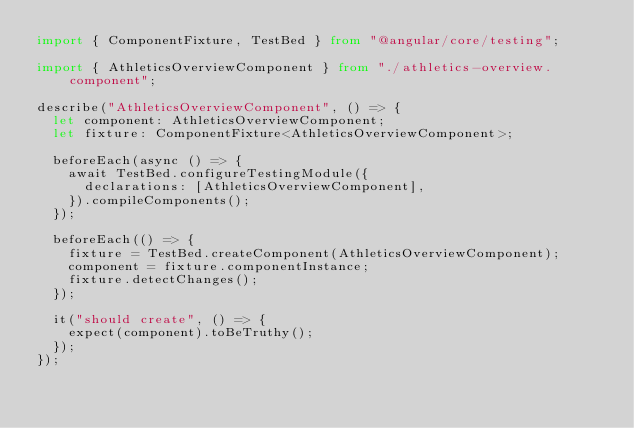<code> <loc_0><loc_0><loc_500><loc_500><_TypeScript_>import { ComponentFixture, TestBed } from "@angular/core/testing";

import { AthleticsOverviewComponent } from "./athletics-overview.component";

describe("AthleticsOverviewComponent", () => {
  let component: AthleticsOverviewComponent;
  let fixture: ComponentFixture<AthleticsOverviewComponent>;

  beforeEach(async () => {
    await TestBed.configureTestingModule({
      declarations: [AthleticsOverviewComponent],
    }).compileComponents();
  });

  beforeEach(() => {
    fixture = TestBed.createComponent(AthleticsOverviewComponent);
    component = fixture.componentInstance;
    fixture.detectChanges();
  });

  it("should create", () => {
    expect(component).toBeTruthy();
  });
});
</code> 